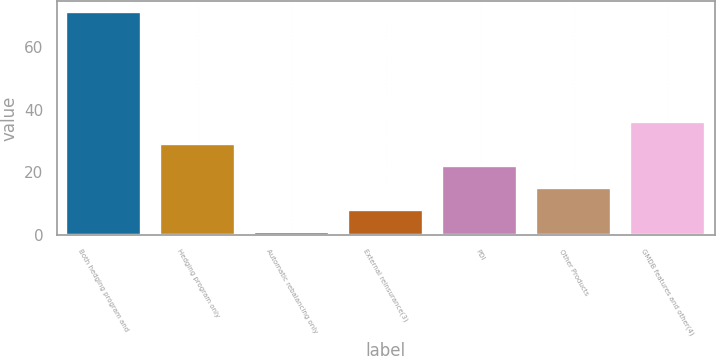<chart> <loc_0><loc_0><loc_500><loc_500><bar_chart><fcel>Both hedging program and<fcel>Hedging program only<fcel>Automatic rebalancing only<fcel>External reinsurance(3)<fcel>PDI<fcel>Other Products<fcel>GMDB features and other(4)<nl><fcel>71<fcel>29<fcel>1<fcel>8<fcel>22<fcel>15<fcel>36<nl></chart> 